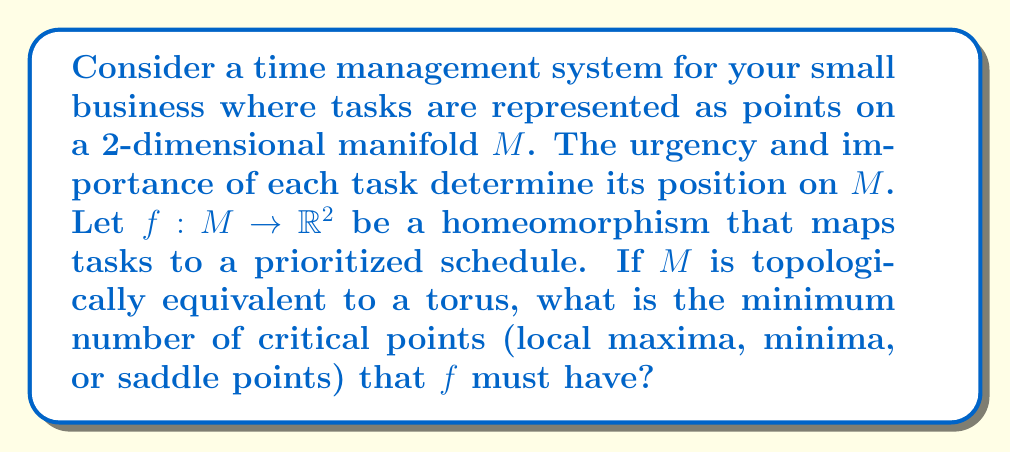Help me with this question. To solve this problem, we need to apply concepts from differential topology, specifically the Morse theory. Let's break it down step-by-step:

1) First, recall that a torus is a closed, orientable surface of genus 1. Its Euler characteristic $\chi$ is given by:

   $$\chi = 2 - 2g = 2 - 2(1) = 0$$

   where $g$ is the genus.

2) The Morse-Euler relation states that for a Morse function $f$ on a compact manifold $M$:

   $$\sum_{i=0}^n (-1)^i c_i = \chi(M)$$

   where $c_i$ is the number of critical points of index $i$, and $\chi(M)$ is the Euler characteristic of $M$.

3) For a 2-dimensional manifold, we have three types of critical points:
   - Minima (index 0)
   - Saddle points (index 1)
   - Maxima (index 2)

4) Let's denote the number of these points as $m$, $s$, and $M$ respectively. The Morse-Euler relation becomes:

   $$m - s + M = \chi(M) = 0$$

5) The minimum number of critical points occurs when $m = s = M = 1$, giving a total of 3 critical points.

6) We can verify that this satisfies the equation:

   $$1 - 1 + 1 = 0$$

7) Any fewer critical points would not satisfy the Morse-Euler relation for a torus.

In the context of time management, these critical points could represent:
- Minimum: A task of lowest priority
- Saddle point: A task of medium priority
- Maximum: A task of highest priority

This topological approach ensures that your prioritization system (represented by $f$) captures the essential structure of your tasks, maintaining their relative importance and urgency while mapping them to a schedule.
Answer: The minimum number of critical points that $f$ must have is 3. 